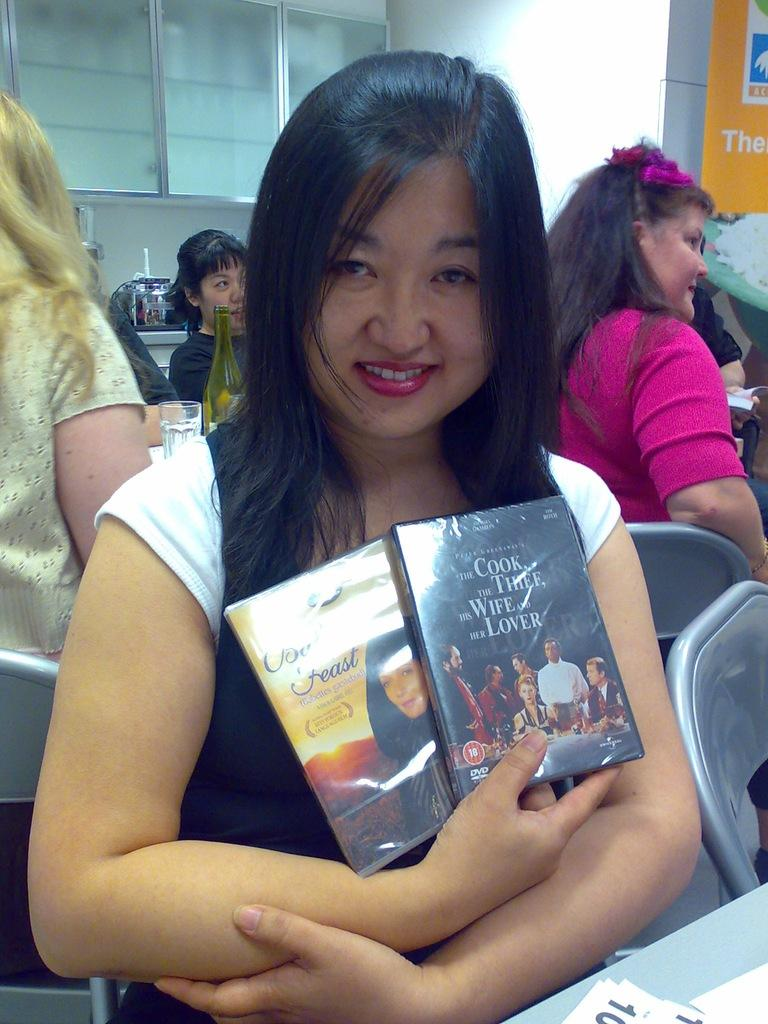<image>
Present a compact description of the photo's key features. A woman holding 2 DVDs of which one is titled The Cook, The Thief, His Wife and Her Lover. 